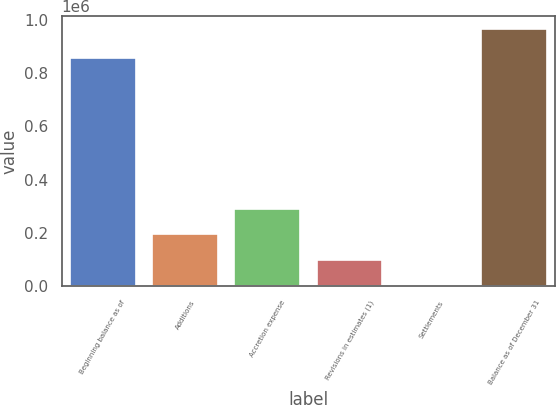Convert chart. <chart><loc_0><loc_0><loc_500><loc_500><bar_chart><fcel>Beginning balance as of<fcel>Additions<fcel>Accretion expense<fcel>Revisions in estimates (1)<fcel>Settlements<fcel>Balance as of December 31<nl><fcel>856936<fcel>194222<fcel>290633<fcel>97811.6<fcel>1401<fcel>965507<nl></chart> 